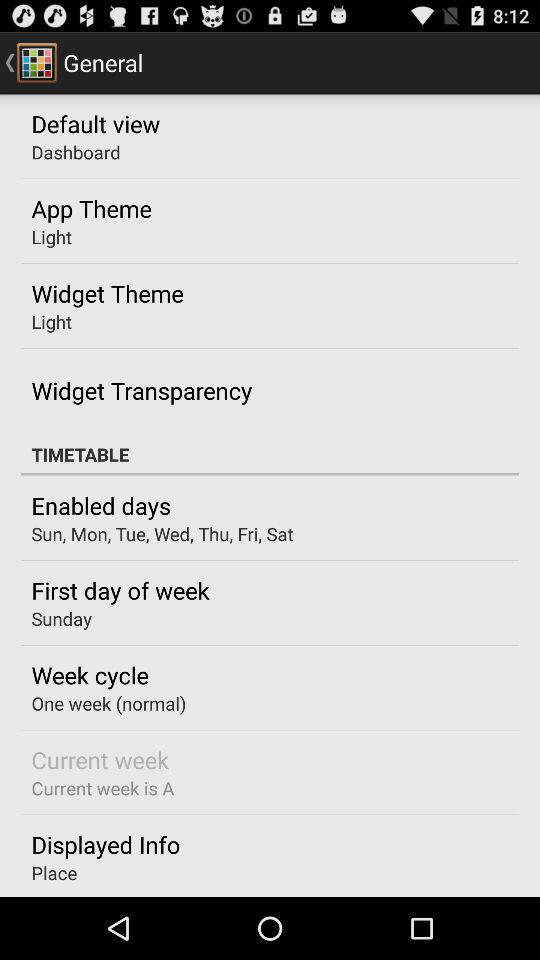Which widget themes are available?
When the provided information is insufficient, respond with <no answer>. <no answer> 